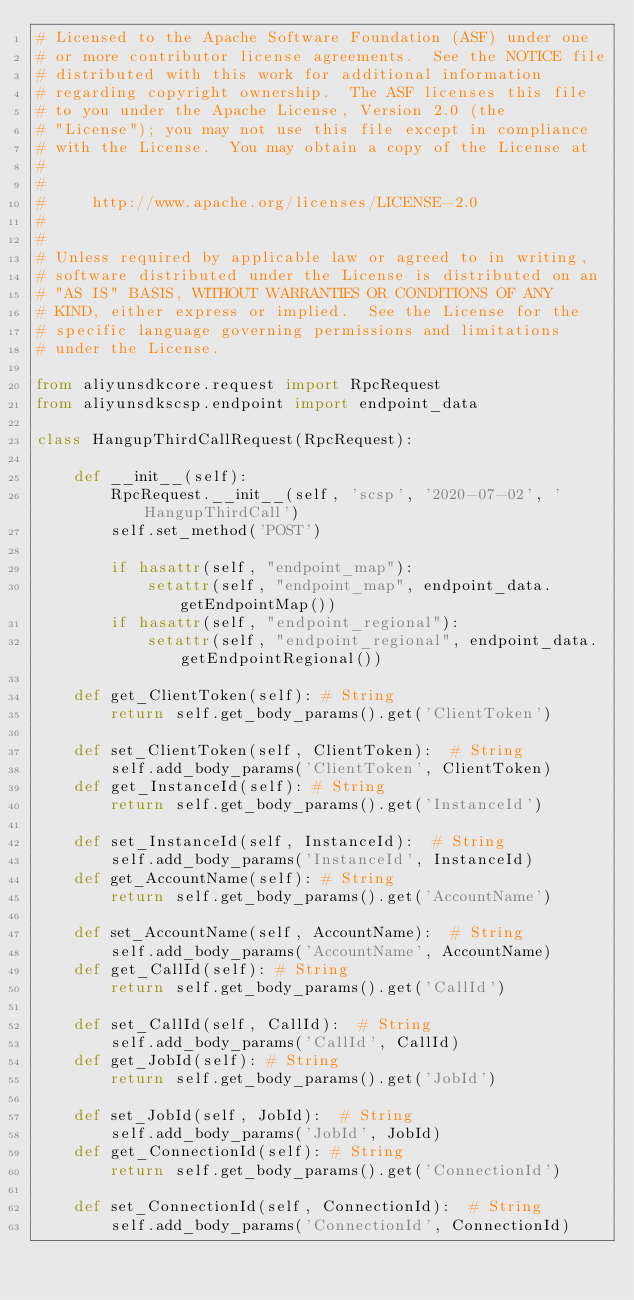<code> <loc_0><loc_0><loc_500><loc_500><_Python_># Licensed to the Apache Software Foundation (ASF) under one
# or more contributor license agreements.  See the NOTICE file
# distributed with this work for additional information
# regarding copyright ownership.  The ASF licenses this file
# to you under the Apache License, Version 2.0 (the
# "License"); you may not use this file except in compliance
# with the License.  You may obtain a copy of the License at
#
#
#     http://www.apache.org/licenses/LICENSE-2.0
#
#
# Unless required by applicable law or agreed to in writing,
# software distributed under the License is distributed on an
# "AS IS" BASIS, WITHOUT WARRANTIES OR CONDITIONS OF ANY
# KIND, either express or implied.  See the License for the
# specific language governing permissions and limitations
# under the License.

from aliyunsdkcore.request import RpcRequest
from aliyunsdkscsp.endpoint import endpoint_data

class HangupThirdCallRequest(RpcRequest):

	def __init__(self):
		RpcRequest.__init__(self, 'scsp', '2020-07-02', 'HangupThirdCall')
		self.set_method('POST')

		if hasattr(self, "endpoint_map"):
			setattr(self, "endpoint_map", endpoint_data.getEndpointMap())
		if hasattr(self, "endpoint_regional"):
			setattr(self, "endpoint_regional", endpoint_data.getEndpointRegional())

	def get_ClientToken(self): # String
		return self.get_body_params().get('ClientToken')

	def set_ClientToken(self, ClientToken):  # String
		self.add_body_params('ClientToken', ClientToken)
	def get_InstanceId(self): # String
		return self.get_body_params().get('InstanceId')

	def set_InstanceId(self, InstanceId):  # String
		self.add_body_params('InstanceId', InstanceId)
	def get_AccountName(self): # String
		return self.get_body_params().get('AccountName')

	def set_AccountName(self, AccountName):  # String
		self.add_body_params('AccountName', AccountName)
	def get_CallId(self): # String
		return self.get_body_params().get('CallId')

	def set_CallId(self, CallId):  # String
		self.add_body_params('CallId', CallId)
	def get_JobId(self): # String
		return self.get_body_params().get('JobId')

	def set_JobId(self, JobId):  # String
		self.add_body_params('JobId', JobId)
	def get_ConnectionId(self): # String
		return self.get_body_params().get('ConnectionId')

	def set_ConnectionId(self, ConnectionId):  # String
		self.add_body_params('ConnectionId', ConnectionId)
</code> 